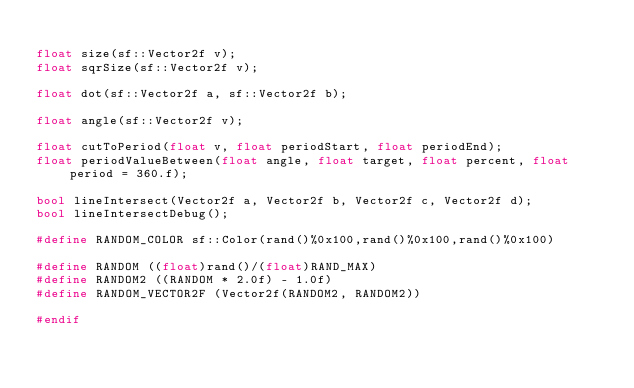<code> <loc_0><loc_0><loc_500><loc_500><_C++_>
float size(sf::Vector2f v);
float sqrSize(sf::Vector2f v);

float dot(sf::Vector2f a, sf::Vector2f b);

float angle(sf::Vector2f v);

float cutToPeriod(float v, float periodStart, float periodEnd);
float periodValueBetween(float angle, float target, float percent, float period = 360.f);

bool lineIntersect(Vector2f a, Vector2f b, Vector2f c, Vector2f d);
bool lineIntersectDebug();

#define RANDOM_COLOR sf::Color(rand()%0x100,rand()%0x100,rand()%0x100)

#define RANDOM ((float)rand()/(float)RAND_MAX)
#define RANDOM2 ((RANDOM * 2.0f) - 1.0f)
#define RANDOM_VECTOR2F (Vector2f(RANDOM2, RANDOM2))

#endif
</code> 